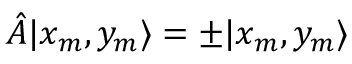<formula> <loc_0><loc_0><loc_500><loc_500>\hat { A } | x _ { m } , y _ { m } \rangle = \pm | x _ { m } , y _ { m } \rangle</formula> 